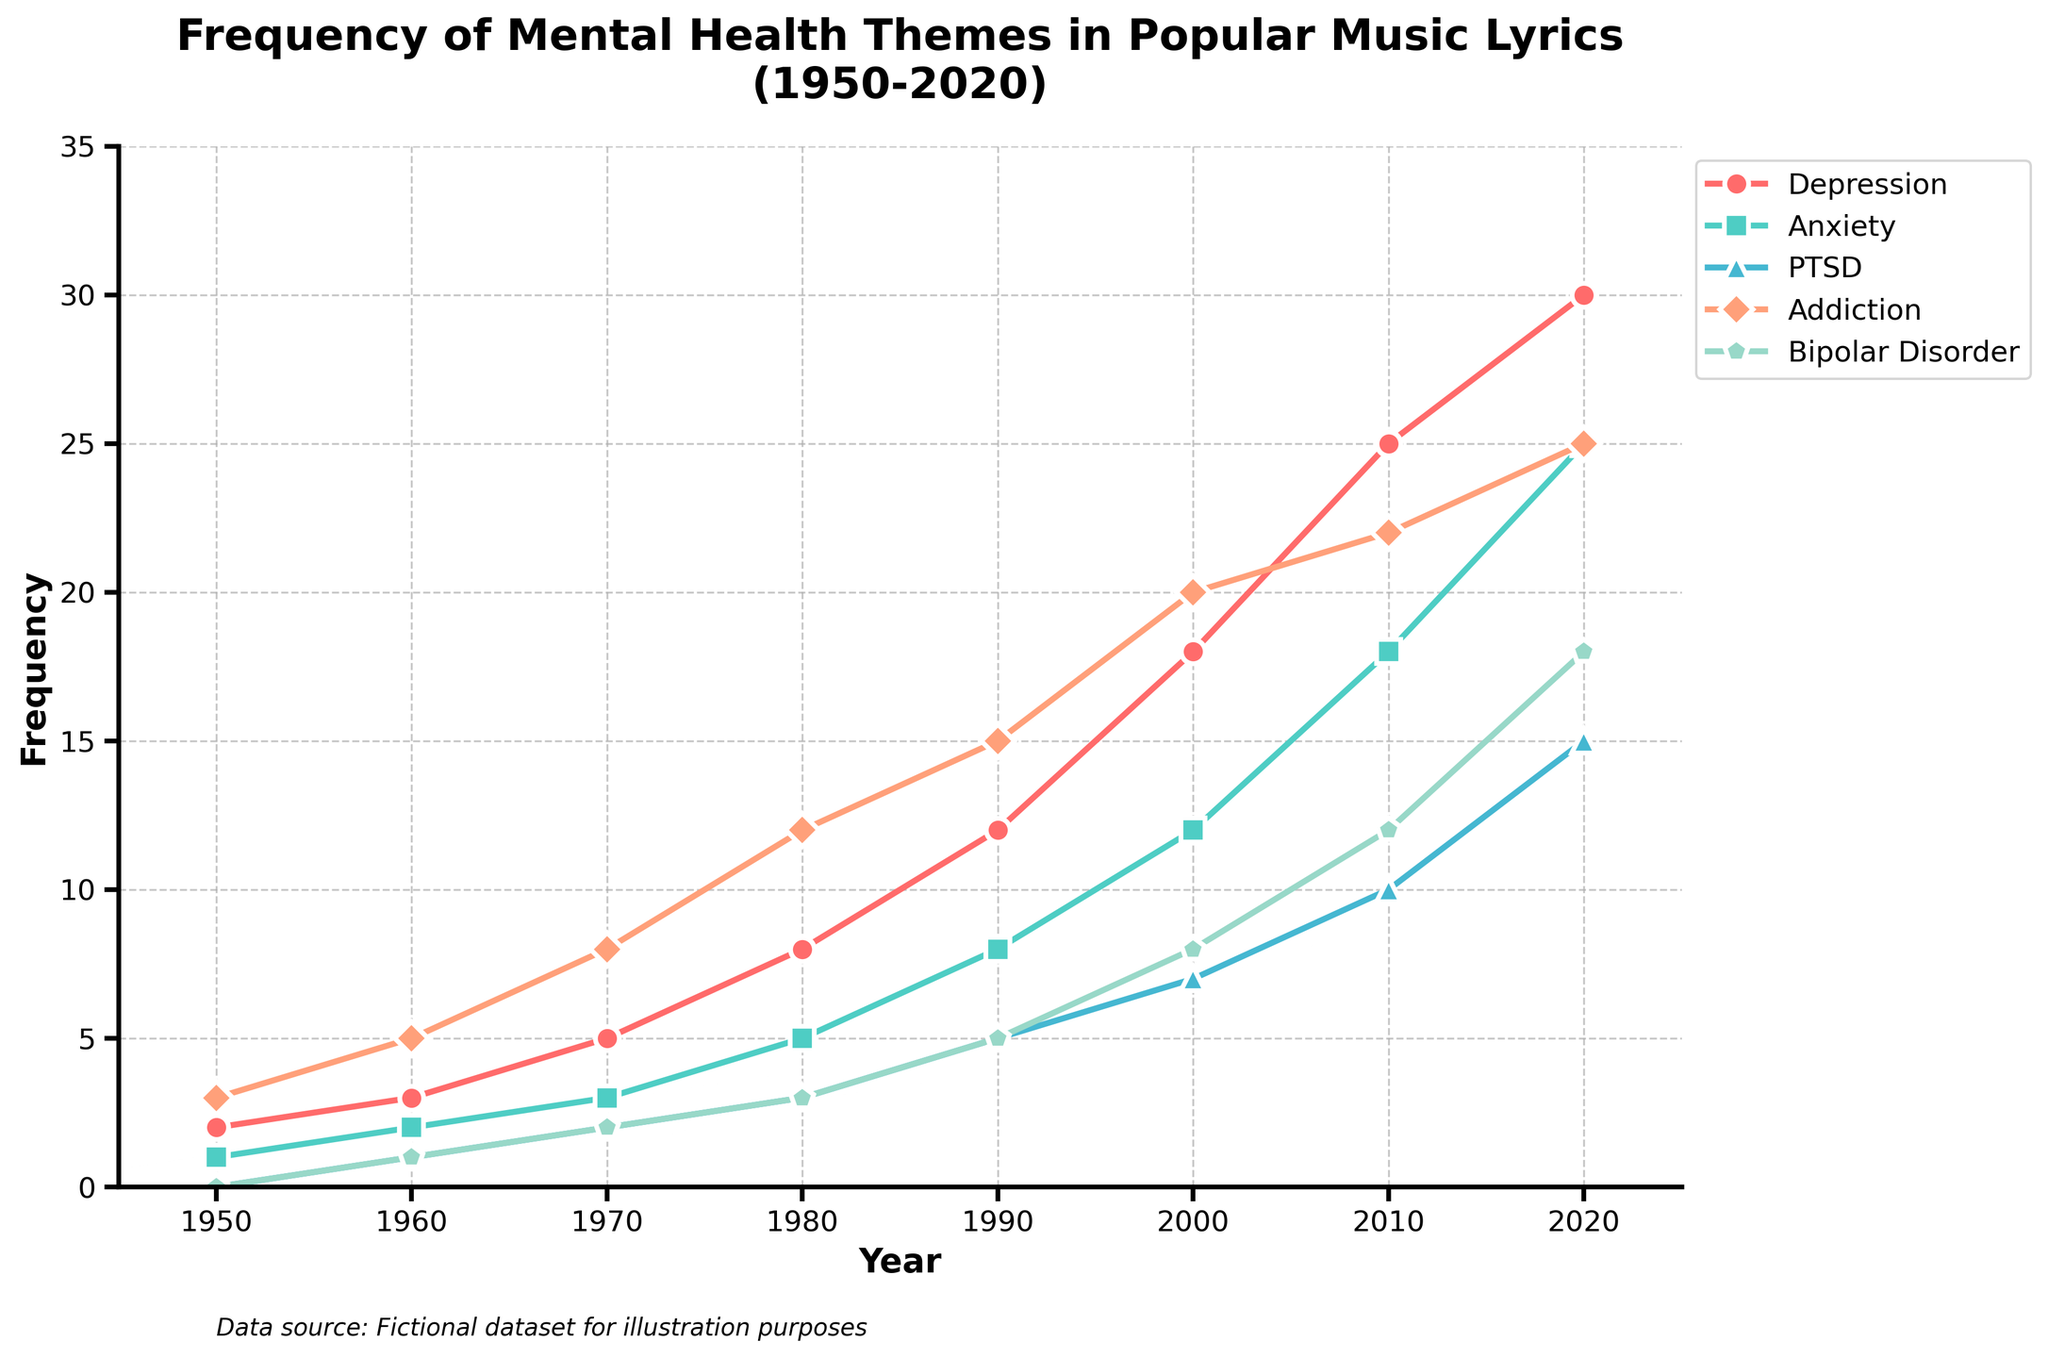Which mental health theme shows the highest frequency in 2020? Observing the chart, the highest point for the year 2020 is for Depression with a frequency of 30.
Answer: Depression By how many units did the frequency of 'Anxiety' increase from 1950 to 2020? The frequency of Anxiety in 1950 was 1, and in 2020 it was 25. The increase is calculated as 25 - 1.
Answer: 24 Which mental health theme had the lowest frequency in 1980? Observing the data points for 1980, PTSD had the lowest frequency with a value of 3.
Answer: PTSD What is the visual color representing 'Addiction,' and what is its frequency in 2010? The color representing 'Addiction' is orange. Observing the point for 2010 on the orange line gives a frequency of 22.
Answer: Orange, 22 Between which two decades did 'Bipolar Disorder' see the highest increase in frequency? Observing the chart, the biggest jump for Bipolar Disorder occurs between the 2010s and the 2020s, from 12 to 18.
Answer: 2010s to 2020s Which mental health themes show an upward trend from 1950 to 2020? Observing the chart, all themes (Depression, Anxiety, PTSD, Addiction, Bipolar Disorder) show an upward trend.
Answer: All themes What is the combined frequency of 'Depression' and 'PTSD' in 1990? The frequency of Depression in 1990 is 12 and for PTSD is 5. Their combined frequency is 12 + 5.
Answer: 17 Which theme had the highest frequency increase during the 2000s? Observing the chart, Depression had the most significant increase, from 18 in 2000 to 25 in 2010, an increase of 7 units.
Answer: Depression How does the frequency of 'Anxiety' in the 2000s compare to the frequency of 'Bipolar Disorder' in the 2020s? In the 2000s, Anxiety's frequency is 12, and in the 2020s, Bipolar Disorder's frequency is 18. Bipolar Disorder in the 2020s is higher than Anxiety in the 2000s.
Answer: Bipolar Disorder in the 2020s is higher 